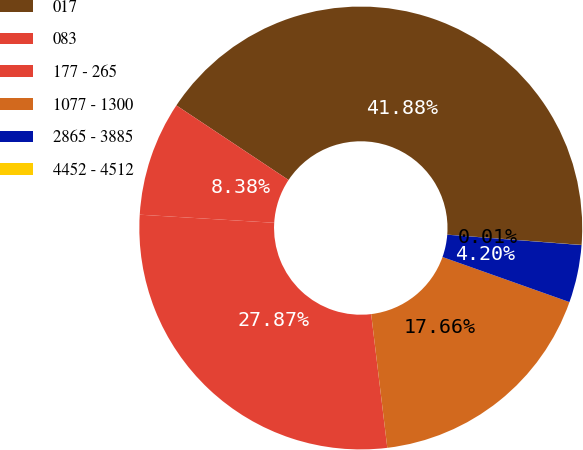<chart> <loc_0><loc_0><loc_500><loc_500><pie_chart><fcel>017<fcel>083<fcel>177 - 265<fcel>1077 - 1300<fcel>2865 - 3885<fcel>4452 - 4512<nl><fcel>41.88%<fcel>8.38%<fcel>27.87%<fcel>17.66%<fcel>4.2%<fcel>0.01%<nl></chart> 